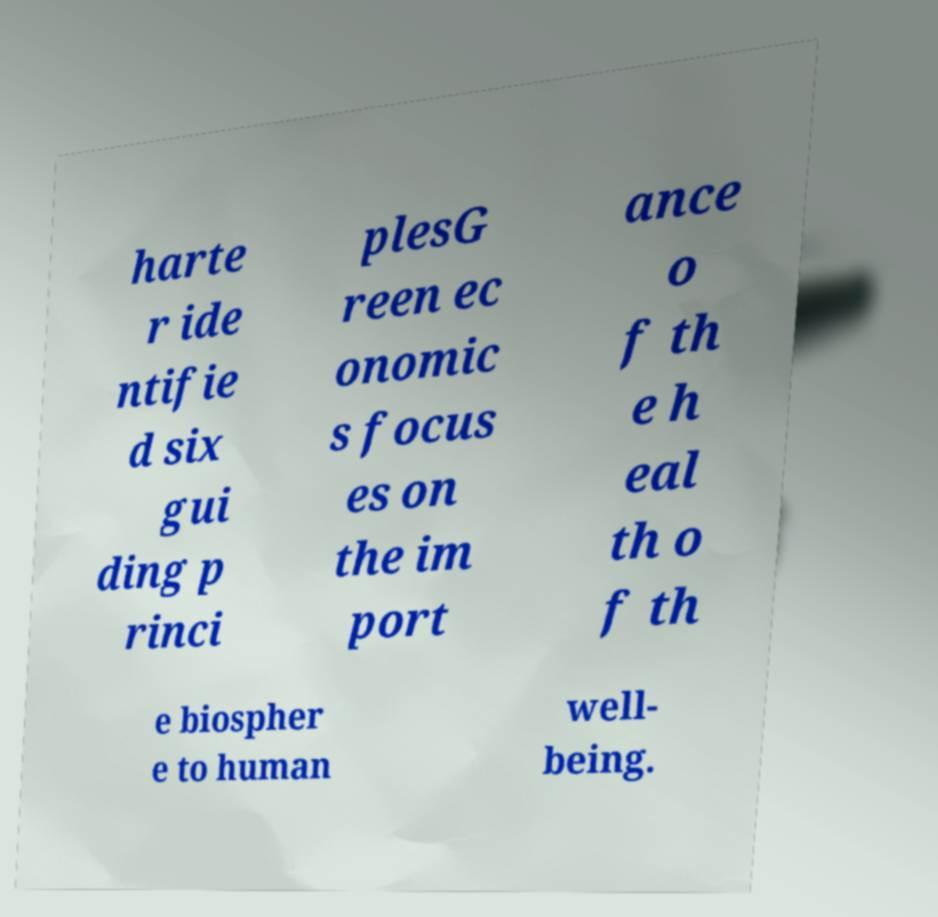There's text embedded in this image that I need extracted. Can you transcribe it verbatim? harte r ide ntifie d six gui ding p rinci plesG reen ec onomic s focus es on the im port ance o f th e h eal th o f th e biospher e to human well- being. 